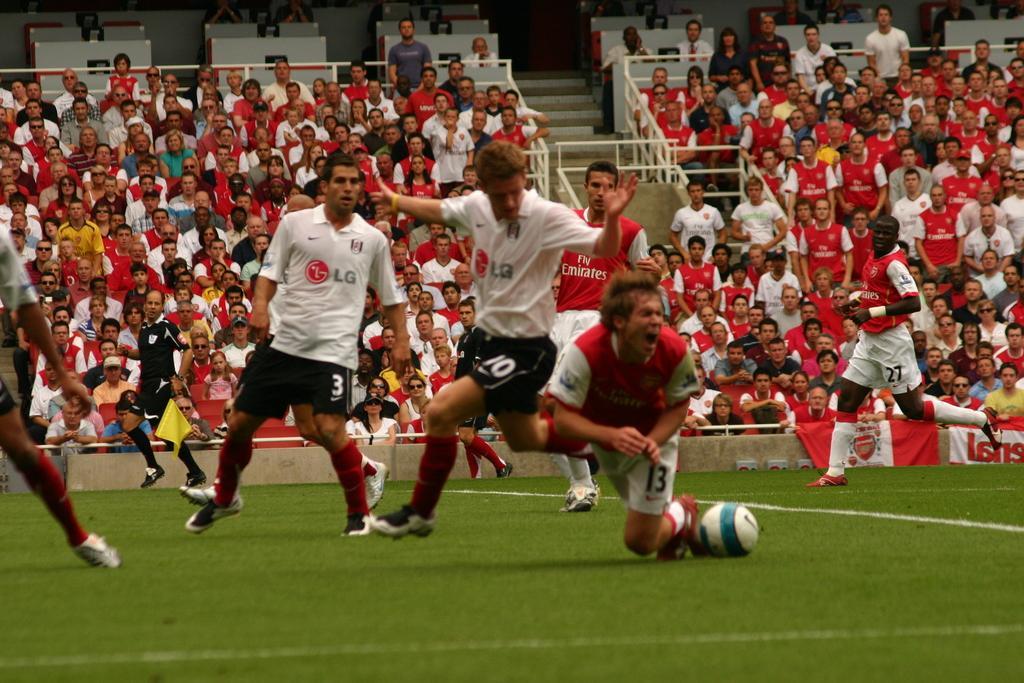Please provide a concise description of this image. In this image i can see football players and at the background of the image there are spectators. 